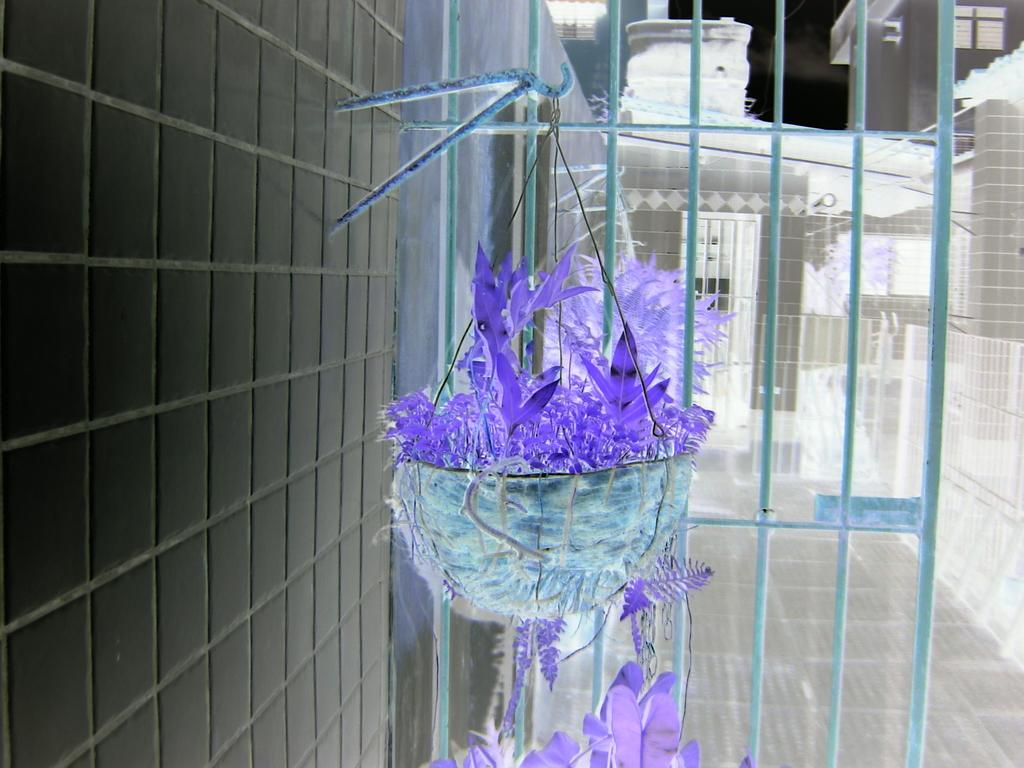What type of plant can be seen in the image? There is a potted plant in the image. What type of structures are visible in the image? There are buildings visible in the image. What is the purpose of the grille in the image? The purpose of the grille in the image is not specified, but it could be for ventilation or security. What is on the left side of the image? There is a wall on the left side of the image. What type of skin is visible on the potted plant in the image? There is no skin visible on the potted plant in the image; it is a plant, not an animal. What team is responsible for maintaining the buildings in the image? There is no information about a team responsible for maintaining the buildings in the image. 